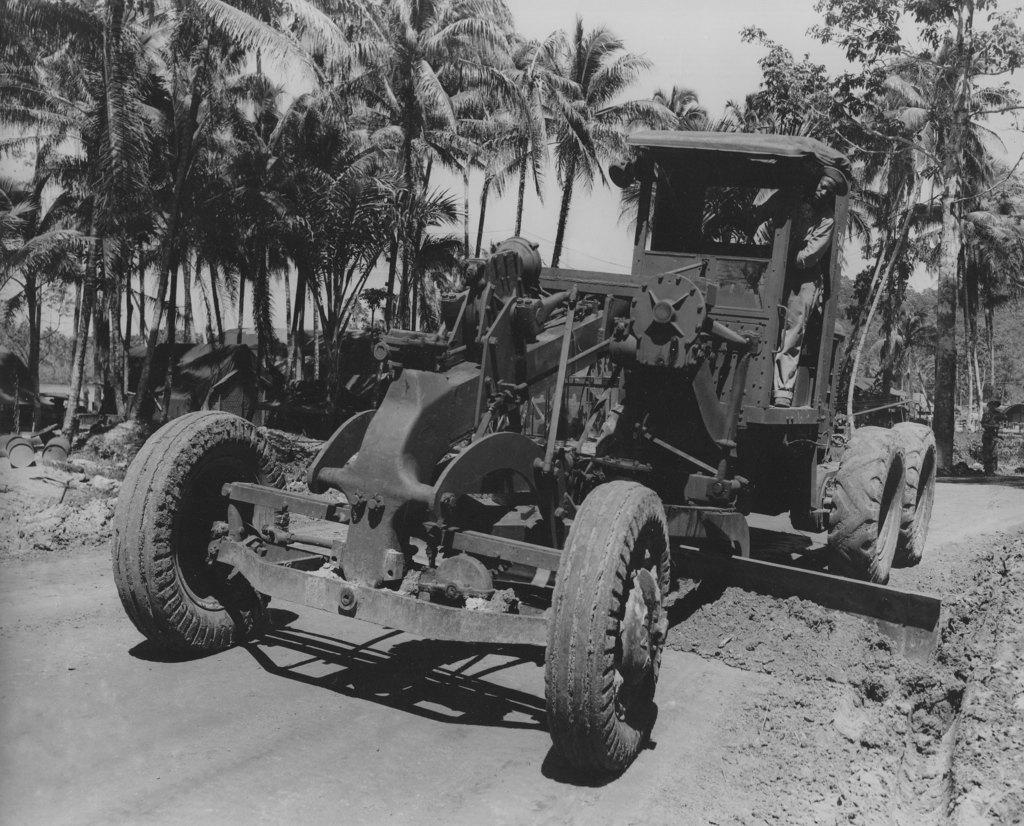What is the color scheme of the image? The image is black and white. What can be seen on the road in the image? There is a vehicle on the road in the image. What type of natural elements can be seen in the background of the image? There are trees in the background of the image. What type of man-made structures can be seen in the background of the image? There are houses in the background of the image. What other objects can be seen in the background of the image? There are drums and other objects in the background of the image. What part of the natural environment is visible in the background of the image? The sky is visible in the background of the image. How many balls are visible in the image? There are no balls present in the image. What type of crib is shown in the image? There is no crib present in the image. 